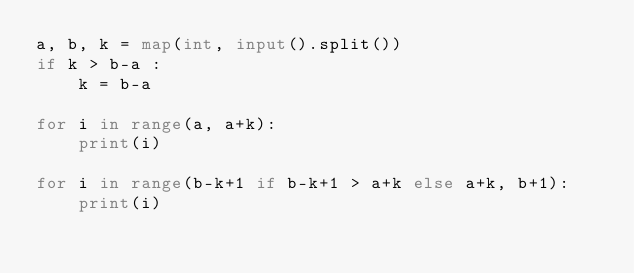<code> <loc_0><loc_0><loc_500><loc_500><_Python_>a, b, k = map(int, input().split())
if k > b-a :
    k = b-a

for i in range(a, a+k):
    print(i)

for i in range(b-k+1 if b-k+1 > a+k else a+k, b+1):
    print(i)</code> 